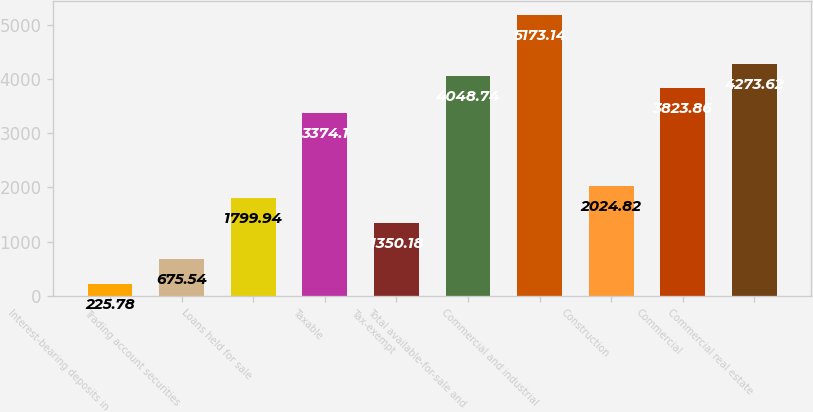Convert chart. <chart><loc_0><loc_0><loc_500><loc_500><bar_chart><fcel>Interest-bearing deposits in<fcel>Trading account securities<fcel>Loans held for sale<fcel>Taxable<fcel>Tax-exempt<fcel>Total available-for-sale and<fcel>Commercial and industrial<fcel>Construction<fcel>Commercial<fcel>Commercial real estate<nl><fcel>225.78<fcel>675.54<fcel>1799.94<fcel>3374.1<fcel>1350.18<fcel>4048.74<fcel>5173.14<fcel>2024.82<fcel>3823.86<fcel>4273.62<nl></chart> 